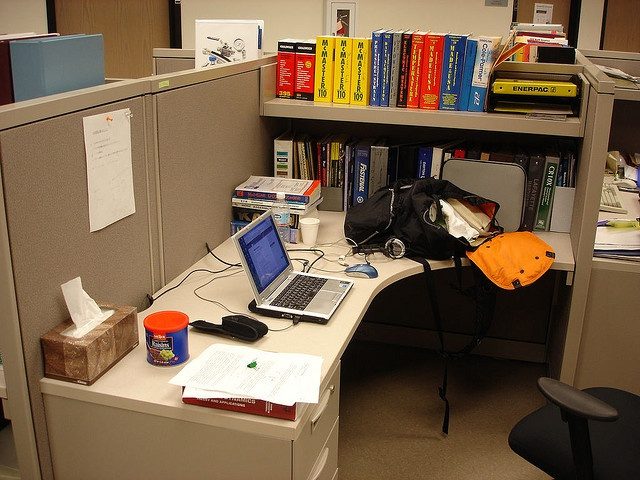Describe the objects in this image and their specific colors. I can see book in gray, black, and tan tones, backpack in gray, black, orange, red, and maroon tones, chair in gray, black, and maroon tones, laptop in gray, blue, black, ivory, and tan tones, and book in gray, maroon, white, tan, and brown tones in this image. 